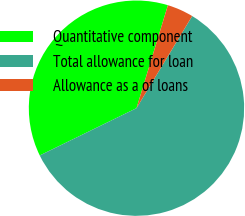Convert chart. <chart><loc_0><loc_0><loc_500><loc_500><pie_chart><fcel>Quantitative component<fcel>Total allowance for loan<fcel>Allowance as a of loans<nl><fcel>36.95%<fcel>59.11%<fcel>3.94%<nl></chart> 